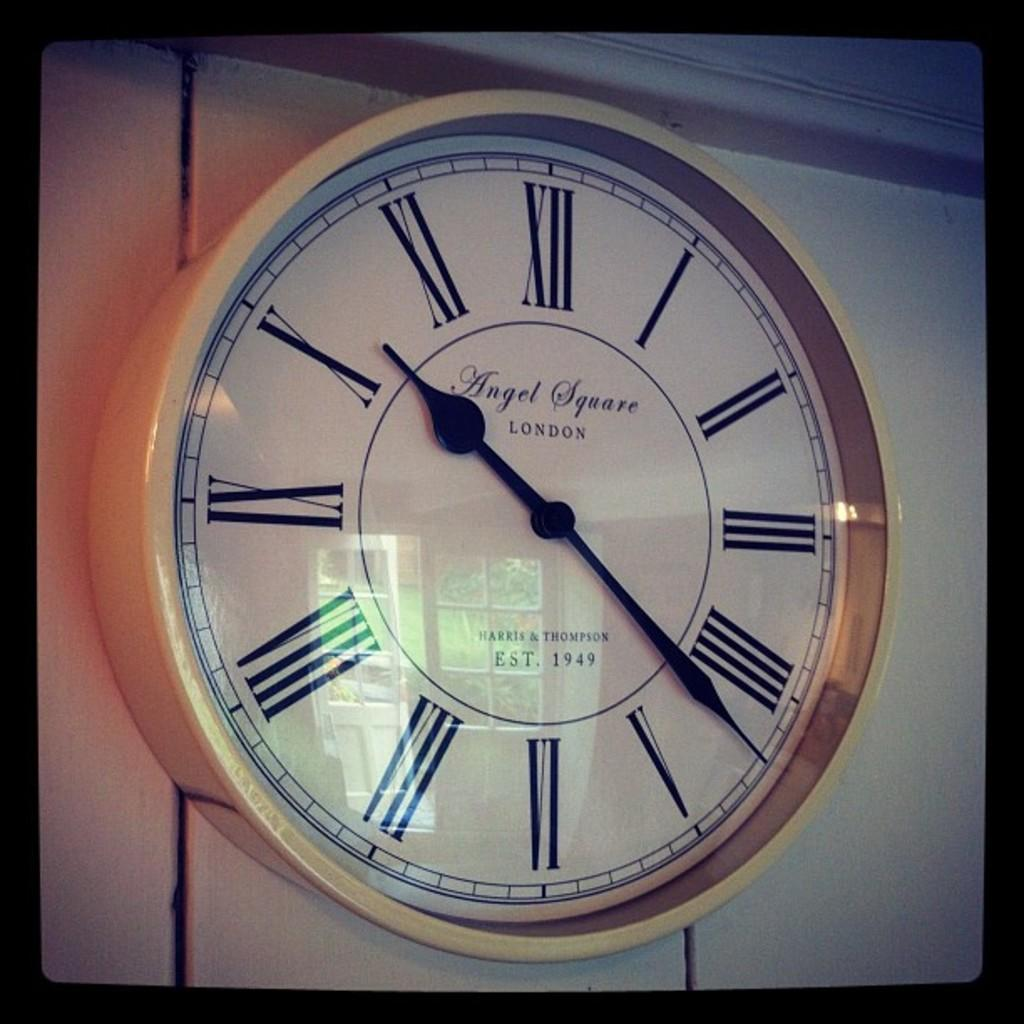<image>
Offer a succinct explanation of the picture presented. Large roman numeral clock by Angel Square London. 